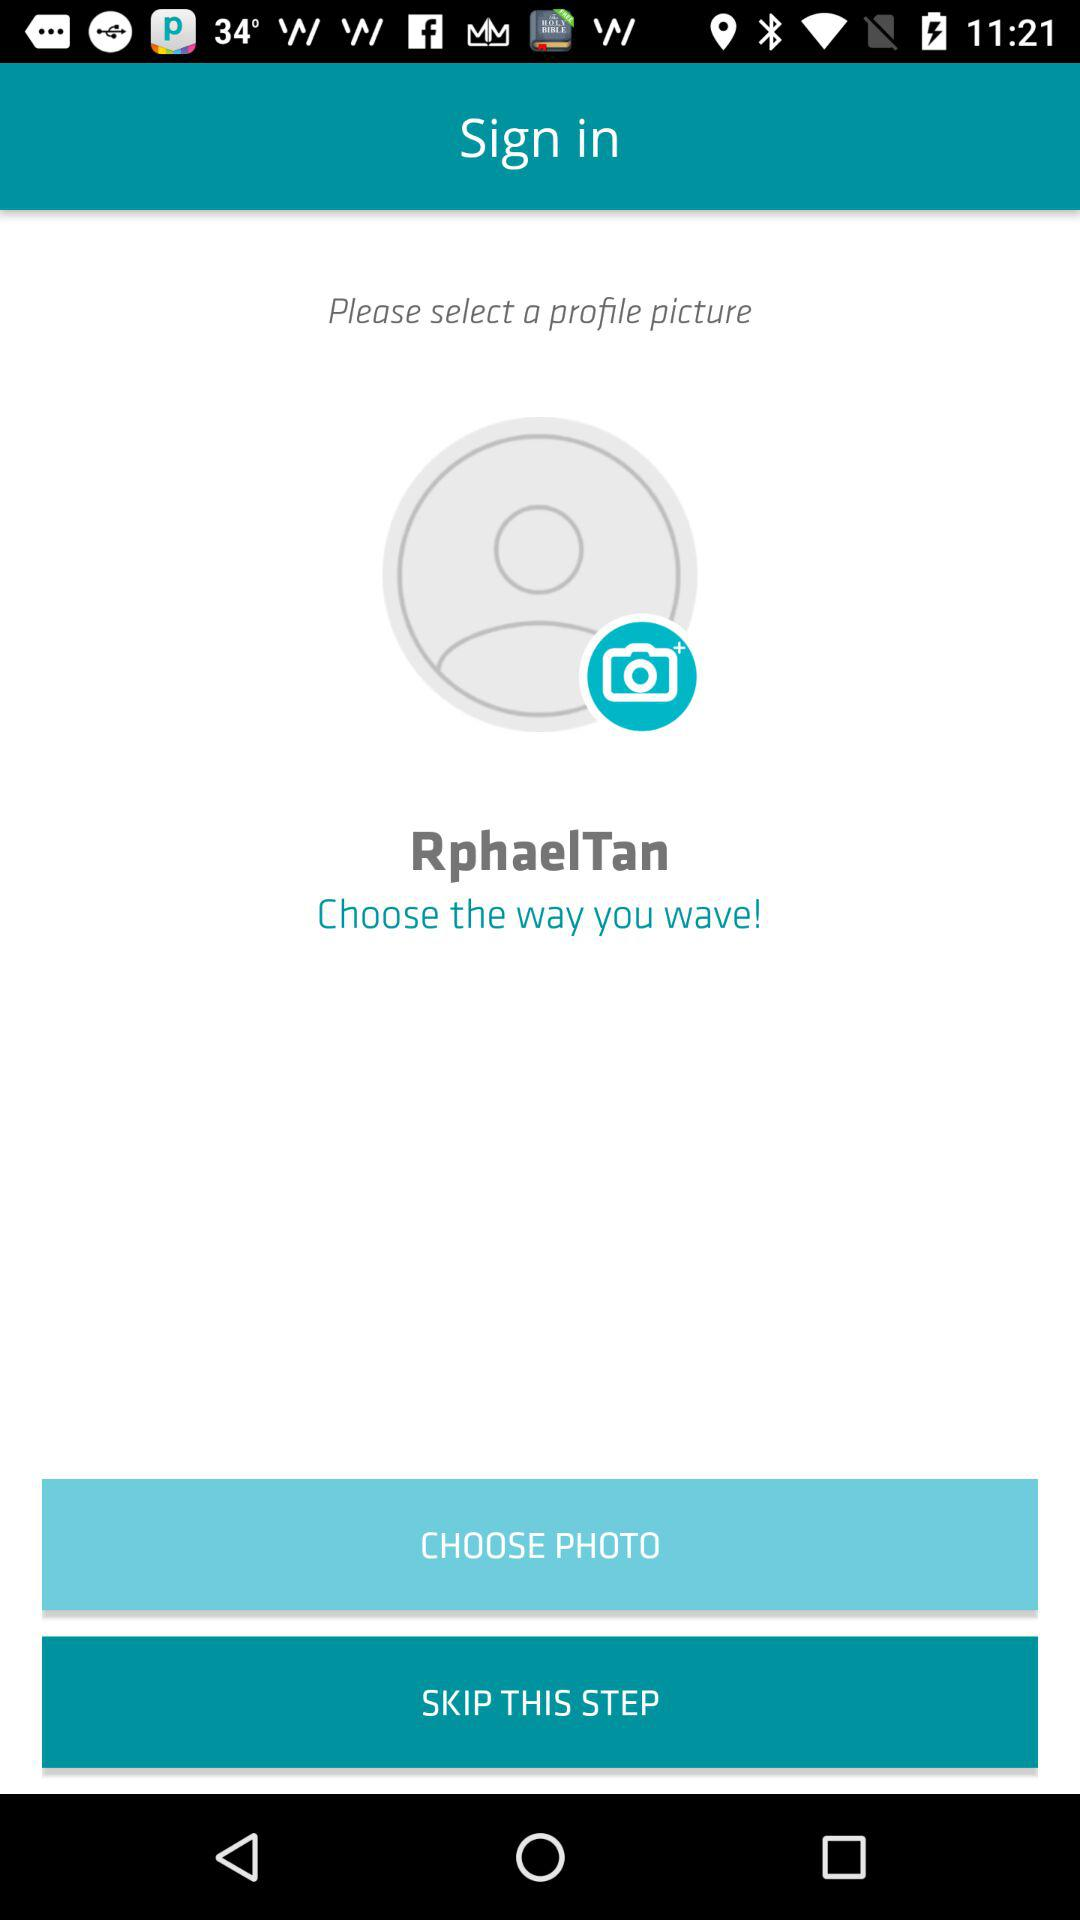How many ways can I select a profile picture?
Answer the question using a single word or phrase. 2 